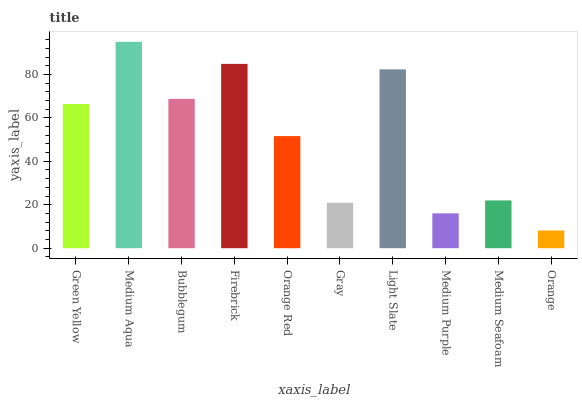Is Orange the minimum?
Answer yes or no. Yes. Is Medium Aqua the maximum?
Answer yes or no. Yes. Is Bubblegum the minimum?
Answer yes or no. No. Is Bubblegum the maximum?
Answer yes or no. No. Is Medium Aqua greater than Bubblegum?
Answer yes or no. Yes. Is Bubblegum less than Medium Aqua?
Answer yes or no. Yes. Is Bubblegum greater than Medium Aqua?
Answer yes or no. No. Is Medium Aqua less than Bubblegum?
Answer yes or no. No. Is Green Yellow the high median?
Answer yes or no. Yes. Is Orange Red the low median?
Answer yes or no. Yes. Is Orange the high median?
Answer yes or no. No. Is Orange the low median?
Answer yes or no. No. 